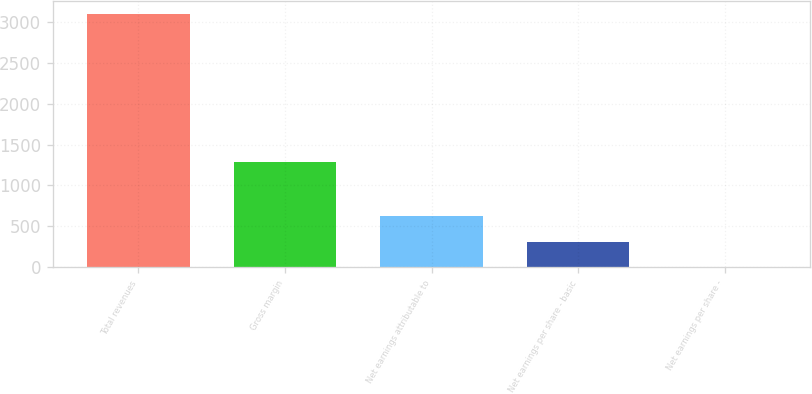Convert chart. <chart><loc_0><loc_0><loc_500><loc_500><bar_chart><fcel>Total revenues<fcel>Gross margin<fcel>Net earnings attributable to<fcel>Net earnings per share - basic<fcel>Net earnings per share -<nl><fcel>3099.1<fcel>1282.7<fcel>623.09<fcel>313.59<fcel>4.09<nl></chart> 